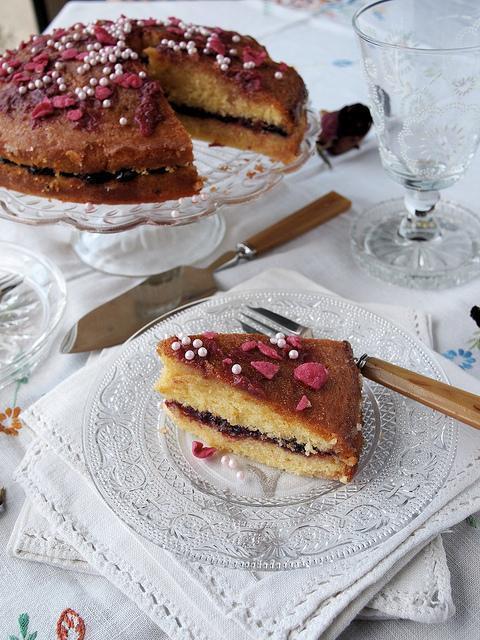How many slices of cake?
Give a very brief answer. 1. How many desserts?
Give a very brief answer. 1. How many cakes are there?
Give a very brief answer. 3. 